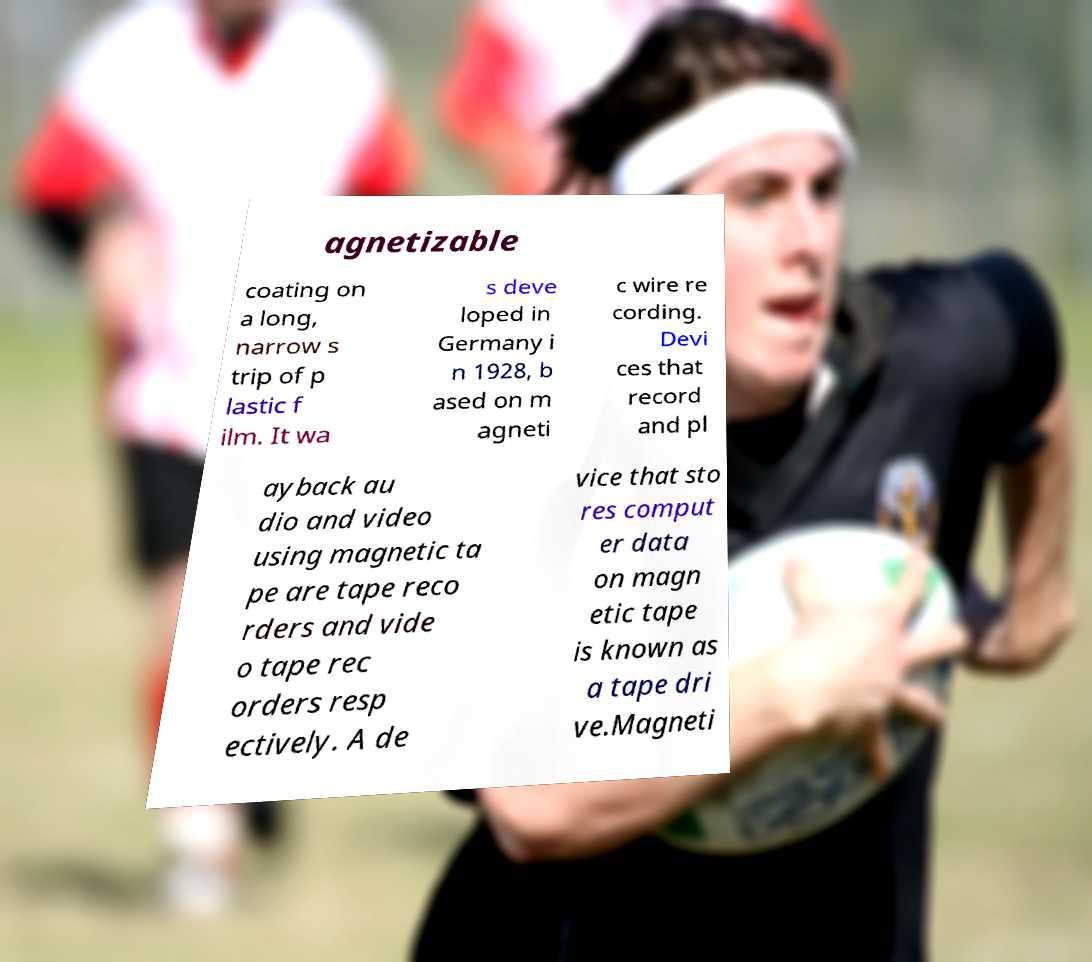What messages or text are displayed in this image? I need them in a readable, typed format. agnetizable coating on a long, narrow s trip of p lastic f ilm. It wa s deve loped in Germany i n 1928, b ased on m agneti c wire re cording. Devi ces that record and pl ayback au dio and video using magnetic ta pe are tape reco rders and vide o tape rec orders resp ectively. A de vice that sto res comput er data on magn etic tape is known as a tape dri ve.Magneti 